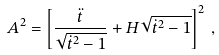<formula> <loc_0><loc_0><loc_500><loc_500>A ^ { 2 } = \left [ \frac { \ddot { t } } { \sqrt { \dot { t } ^ { 2 } - 1 } } + H \sqrt { \dot { t } ^ { 2 } - 1 } \right ] ^ { 2 } \, ,</formula> 